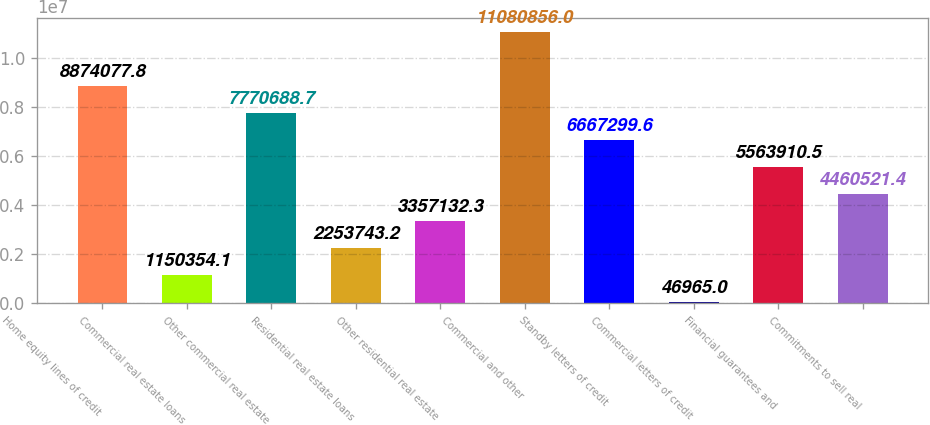Convert chart to OTSL. <chart><loc_0><loc_0><loc_500><loc_500><bar_chart><fcel>Home equity lines of credit<fcel>Commercial real estate loans<fcel>Other commercial real estate<fcel>Residential real estate loans<fcel>Other residential real estate<fcel>Commercial and other<fcel>Standby letters of credit<fcel>Commercial letters of credit<fcel>Financial guarantees and<fcel>Commitments to sell real<nl><fcel>8.87408e+06<fcel>1.15035e+06<fcel>7.77069e+06<fcel>2.25374e+06<fcel>3.35713e+06<fcel>1.10809e+07<fcel>6.6673e+06<fcel>46965<fcel>5.56391e+06<fcel>4.46052e+06<nl></chart> 